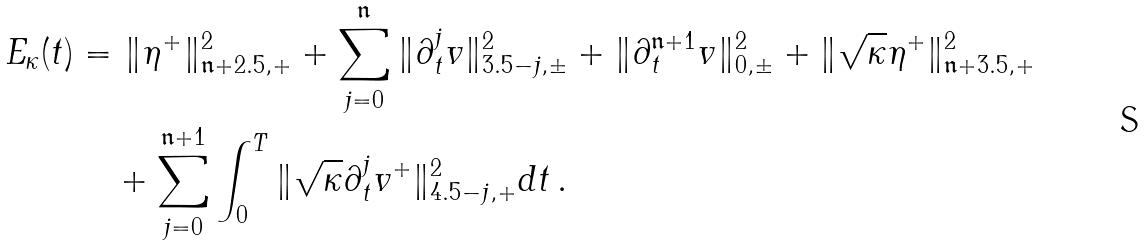Convert formula to latex. <formula><loc_0><loc_0><loc_500><loc_500>E _ { \kappa } ( t ) = & \ \| \eta ^ { + } \| ^ { 2 } _ { { \mathfrak n } + 2 . 5 , + } + \sum _ { j = 0 } ^ { \mathfrak n } \| \partial _ { t } ^ { j } v \| ^ { 2 } _ { 3 . 5 - j , \pm } + \| \partial _ { t } ^ { { \mathfrak n } + 1 } v \| ^ { 2 } _ { 0 , \pm } + \| \sqrt { \kappa } \eta ^ { + } \| ^ { 2 } _ { { \mathfrak n } + 3 . 5 , + } \\ & + \sum _ { j = 0 } ^ { { \mathfrak n } + 1 } \int _ { 0 } ^ { T } \| \sqrt { \kappa } \partial _ { t } ^ { j } v ^ { + } \| ^ { 2 } _ { 4 . 5 - j , + } d t \, .</formula> 